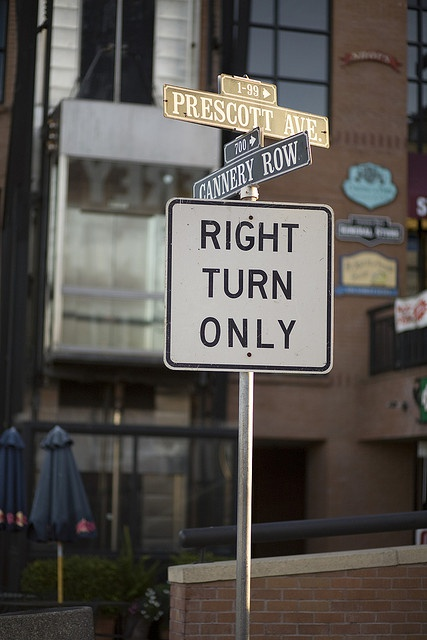Describe the objects in this image and their specific colors. I can see umbrella in black, darkblue, and gray tones and umbrella in black, darkblue, and gray tones in this image. 